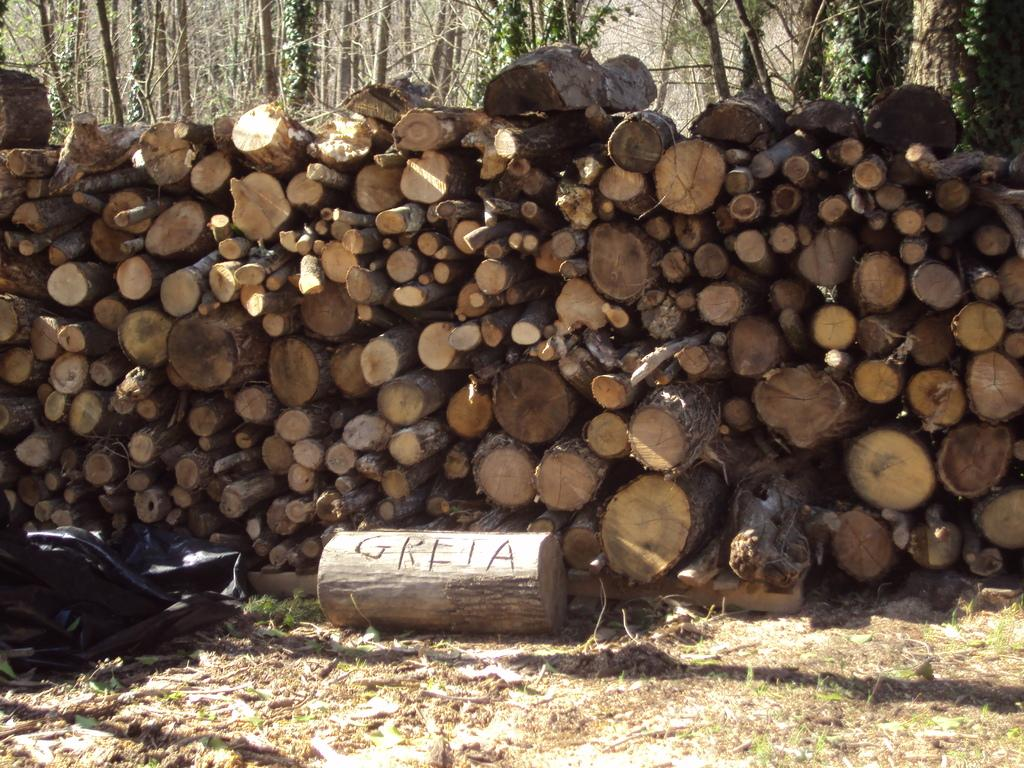What type of surface can be seen in the image? There is ground visible in the image. What is located on the ground in the image? There is a black colored object and wooden logs on the ground. What can be seen in the background of the image? There are trees in the background of the image. What time does the clock show in the image? There is no clock present in the image. How does the gate open in the image? There is no gate present in the image. 